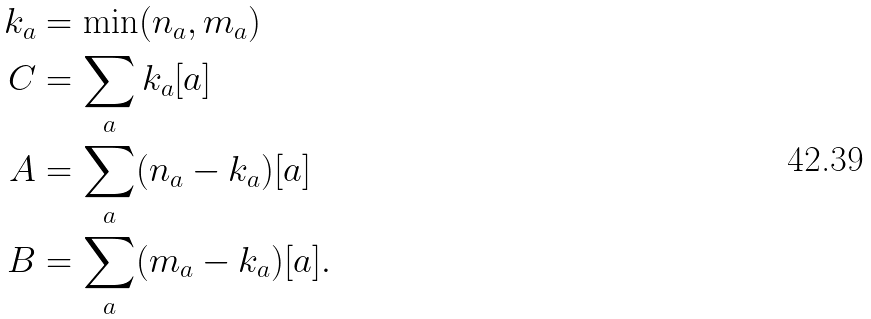<formula> <loc_0><loc_0><loc_500><loc_500>k _ { a } & = \min ( n _ { a } , m _ { a } ) \\ C & = \sum _ { a } k _ { a } [ a ] \\ A & = \sum _ { a } ( n _ { a } - k _ { a } ) [ a ] \\ B & = \sum _ { a } ( m _ { a } - k _ { a } ) [ a ] .</formula> 